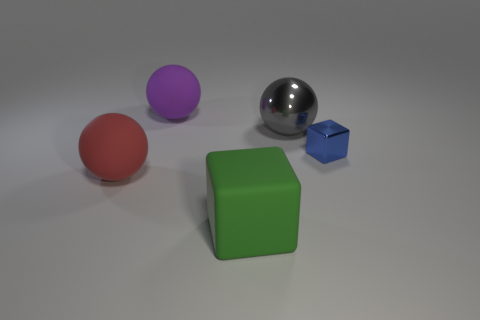What number of other gray things are the same shape as the tiny object?
Give a very brief answer. 0. How many purple rubber things are in front of the big gray metal thing?
Provide a short and direct response. 0. Is the color of the matte ball that is behind the red sphere the same as the shiny sphere?
Offer a terse response. No. What number of cyan metallic cylinders are the same size as the red rubber ball?
Ensure brevity in your answer.  0. What is the shape of the large green thing that is made of the same material as the large red sphere?
Ensure brevity in your answer.  Cube. Are there any large cubes of the same color as the small shiny block?
Your answer should be compact. No. What material is the gray object?
Offer a terse response. Metal. What number of objects are large spheres or large purple spheres?
Provide a succinct answer. 3. What size is the metal object on the left side of the tiny blue shiny cube?
Offer a terse response. Large. How many other things are there of the same material as the big cube?
Offer a terse response. 2. 